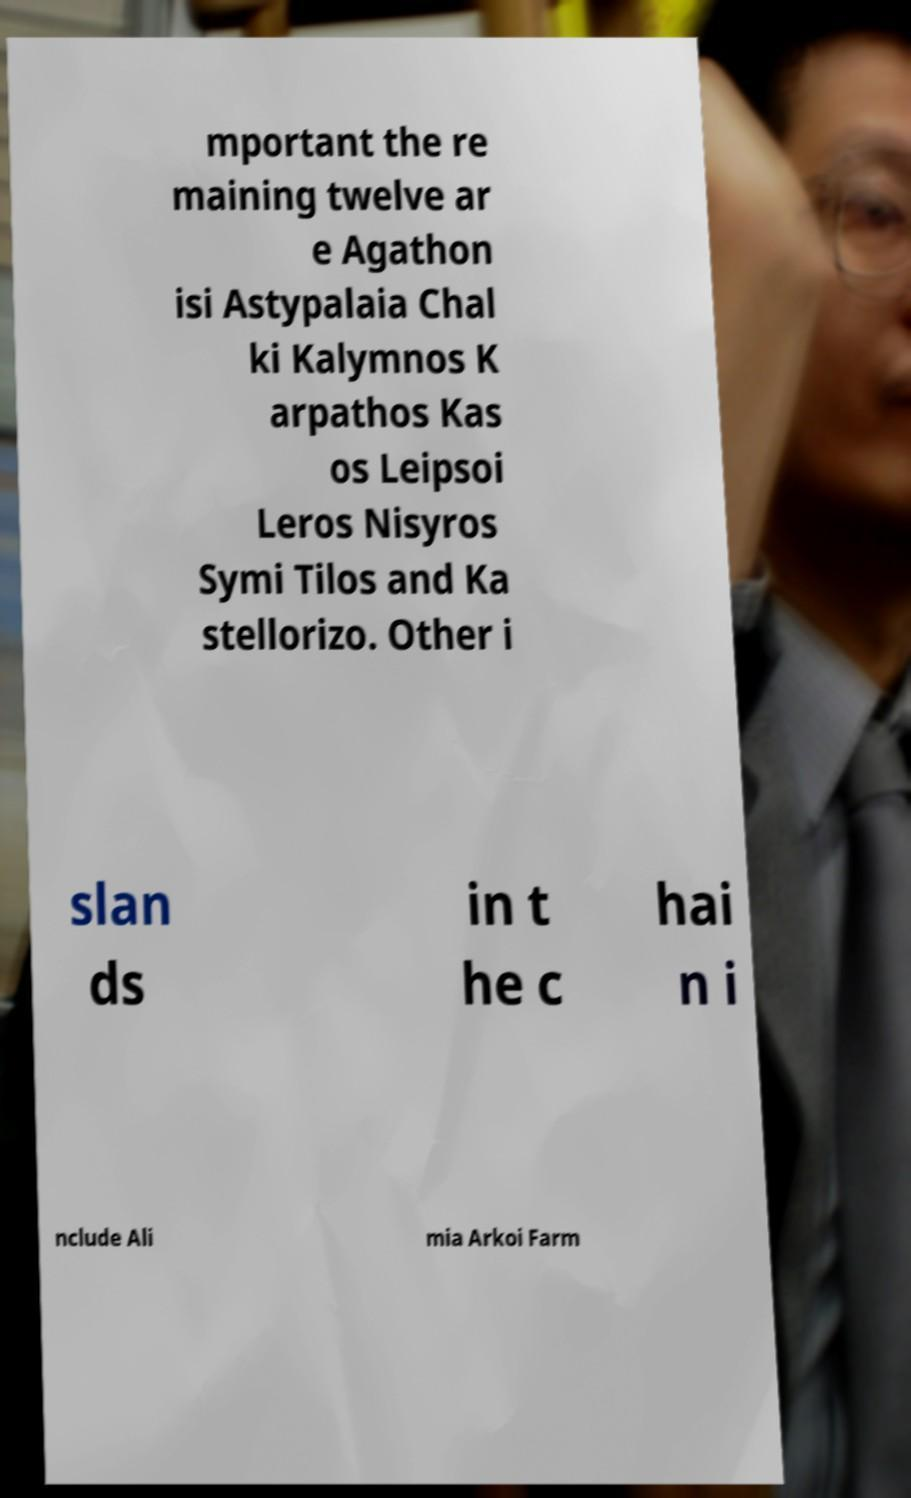For documentation purposes, I need the text within this image transcribed. Could you provide that? mportant the re maining twelve ar e Agathon isi Astypalaia Chal ki Kalymnos K arpathos Kas os Leipsoi Leros Nisyros Symi Tilos and Ka stellorizo. Other i slan ds in t he c hai n i nclude Ali mia Arkoi Farm 